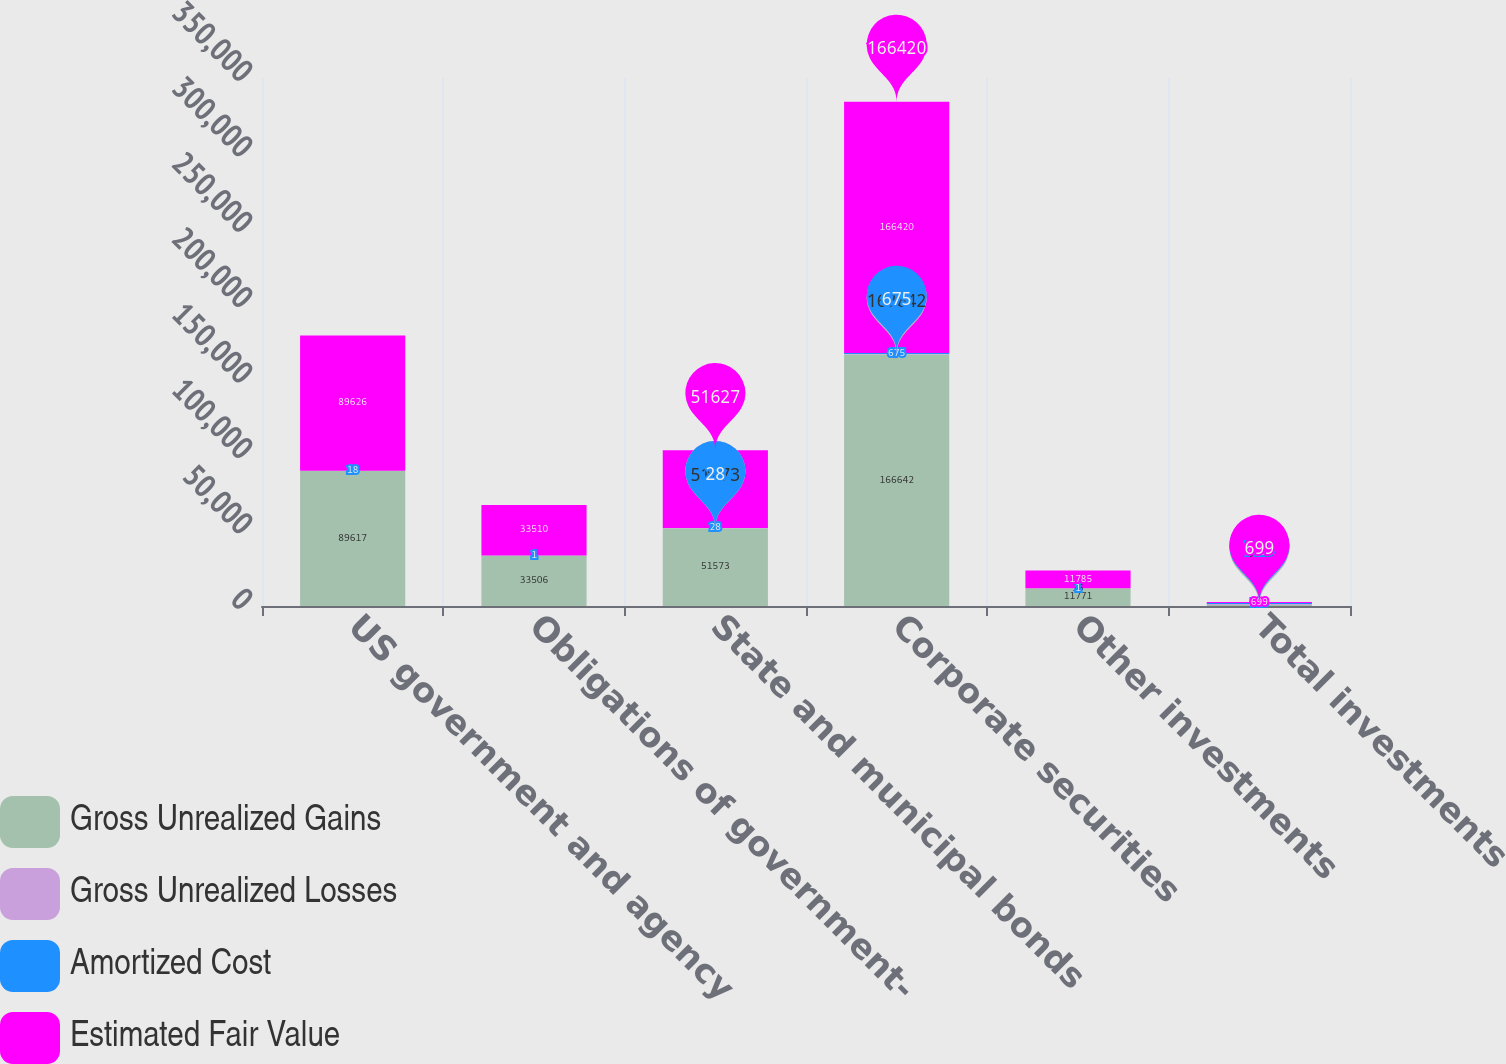<chart> <loc_0><loc_0><loc_500><loc_500><stacked_bar_chart><ecel><fcel>US government and agency<fcel>Obligations of government-<fcel>State and municipal bonds<fcel>Corporate securities<fcel>Other investments<fcel>Total investments<nl><fcel>Gross Unrealized Gains<fcel>89617<fcel>33506<fcel>51573<fcel>166642<fcel>11771<fcel>699<nl><fcel>Gross Unrealized Losses<fcel>27<fcel>5<fcel>82<fcel>453<fcel>15<fcel>582<nl><fcel>Amortized Cost<fcel>18<fcel>1<fcel>28<fcel>675<fcel>1<fcel>723<nl><fcel>Estimated Fair Value<fcel>89626<fcel>33510<fcel>51627<fcel>166420<fcel>11785<fcel>699<nl></chart> 